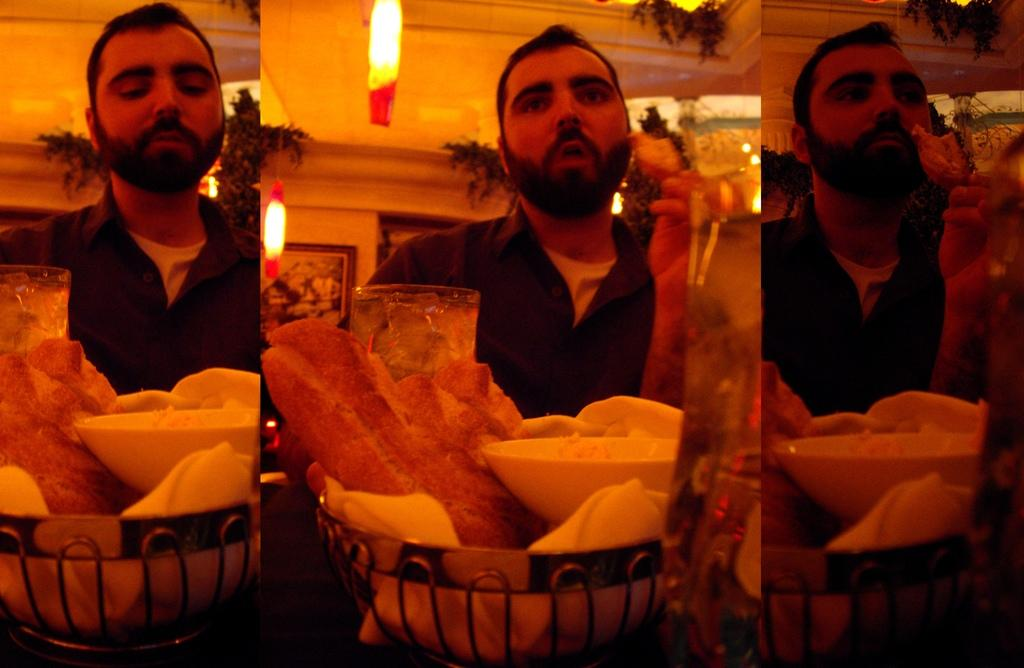What type of photo is shown in the image? The image is a collage photo. How many lights can be seen in the image? There are two lights in the image. What is attached to the wall in the image? There is a frame attached to the wall in the image. What is on the table in the image? There are objects on a table in the image. What can be seen in the background of the image? Trees are visible in the image. What is the person in the image doing? There is a person sitting and eating in the image. What color is the wing of the bird flying in the image? There is no bird or wing present in the image. What is the chance of the person in the image winning the lottery? The image does not provide any information about the person's chances of winning the lottery. 